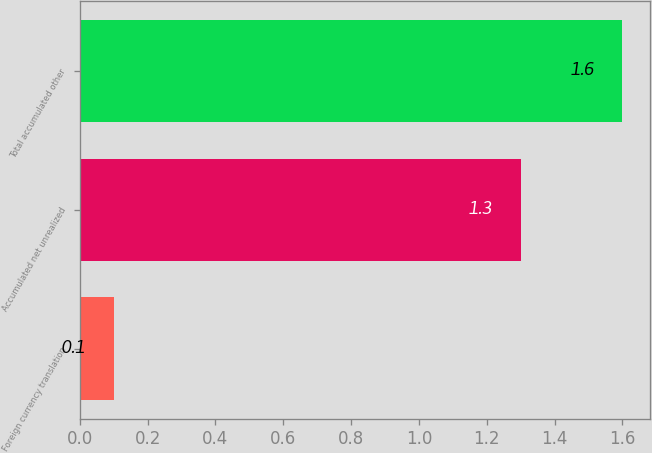<chart> <loc_0><loc_0><loc_500><loc_500><bar_chart><fcel>Foreign currency translation<fcel>Accumulated net unrealized<fcel>Total accumulated other<nl><fcel>0.1<fcel>1.3<fcel>1.6<nl></chart> 